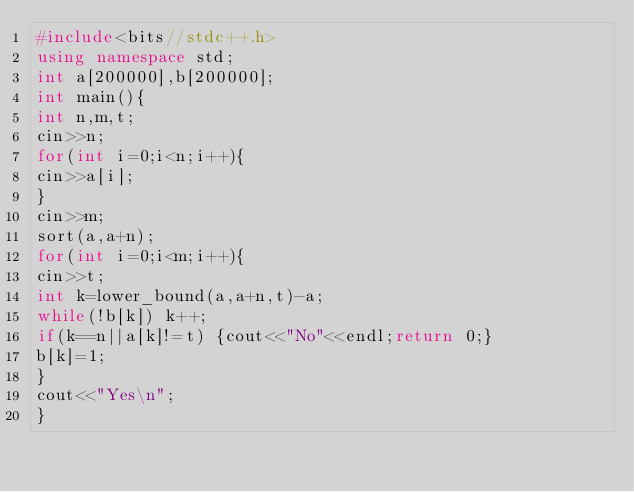Convert code to text. <code><loc_0><loc_0><loc_500><loc_500><_C++_>#include<bits//stdc++.h>
using namespace std;
int a[200000],b[200000];
int main(){
int n,m,t;
cin>>n;
for(int i=0;i<n;i++){
cin>>a[i];
}
cin>>m;
sort(a,a+n);
for(int i=0;i<m;i++){
cin>>t;
int k=lower_bound(a,a+n,t)-a;
while(!b[k]) k++;
if(k==n||a[k]!=t) {cout<<"No"<<endl;return 0;}
b[k]=1;
}
cout<<"Yes\n";
}</code> 